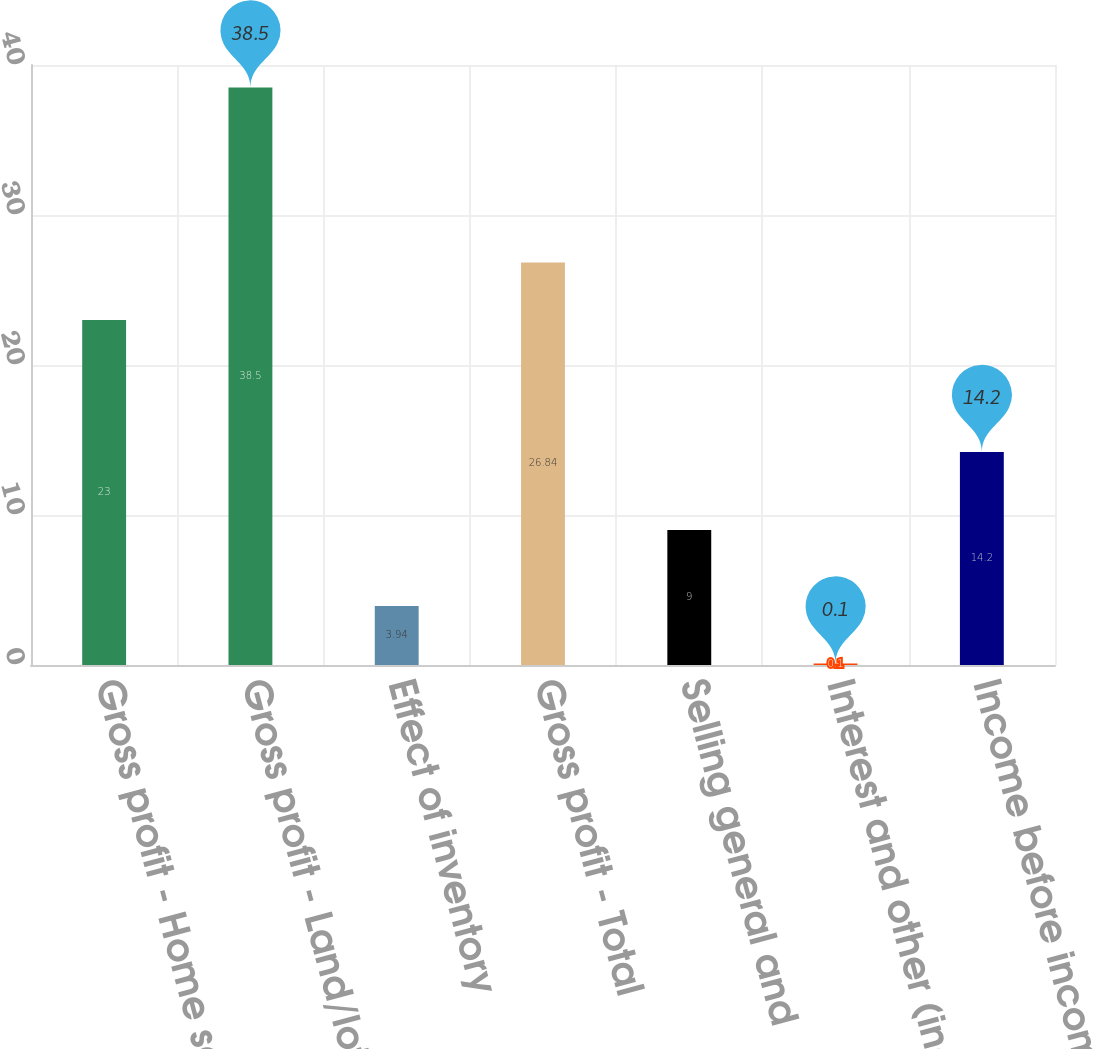Convert chart. <chart><loc_0><loc_0><loc_500><loc_500><bar_chart><fcel>Gross profit - Home sales<fcel>Gross profit - Land/lot sales<fcel>Effect of inventory<fcel>Gross profit - Total<fcel>Selling general and<fcel>Interest and other (income)<fcel>Income before income taxes<nl><fcel>23<fcel>38.5<fcel>3.94<fcel>26.84<fcel>9<fcel>0.1<fcel>14.2<nl></chart> 